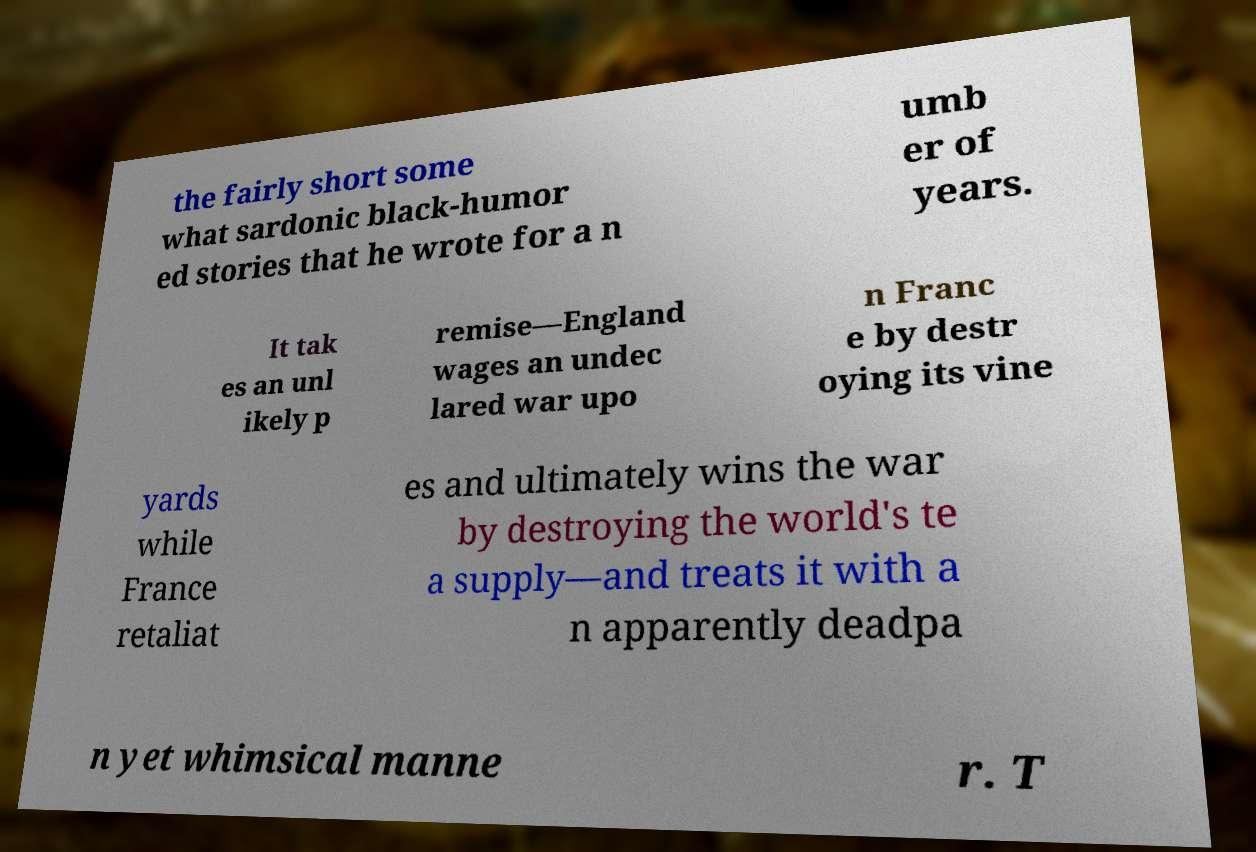What messages or text are displayed in this image? I need them in a readable, typed format. the fairly short some what sardonic black-humor ed stories that he wrote for a n umb er of years. It tak es an unl ikely p remise—England wages an undec lared war upo n Franc e by destr oying its vine yards while France retaliat es and ultimately wins the war by destroying the world's te a supply—and treats it with a n apparently deadpa n yet whimsical manne r. T 